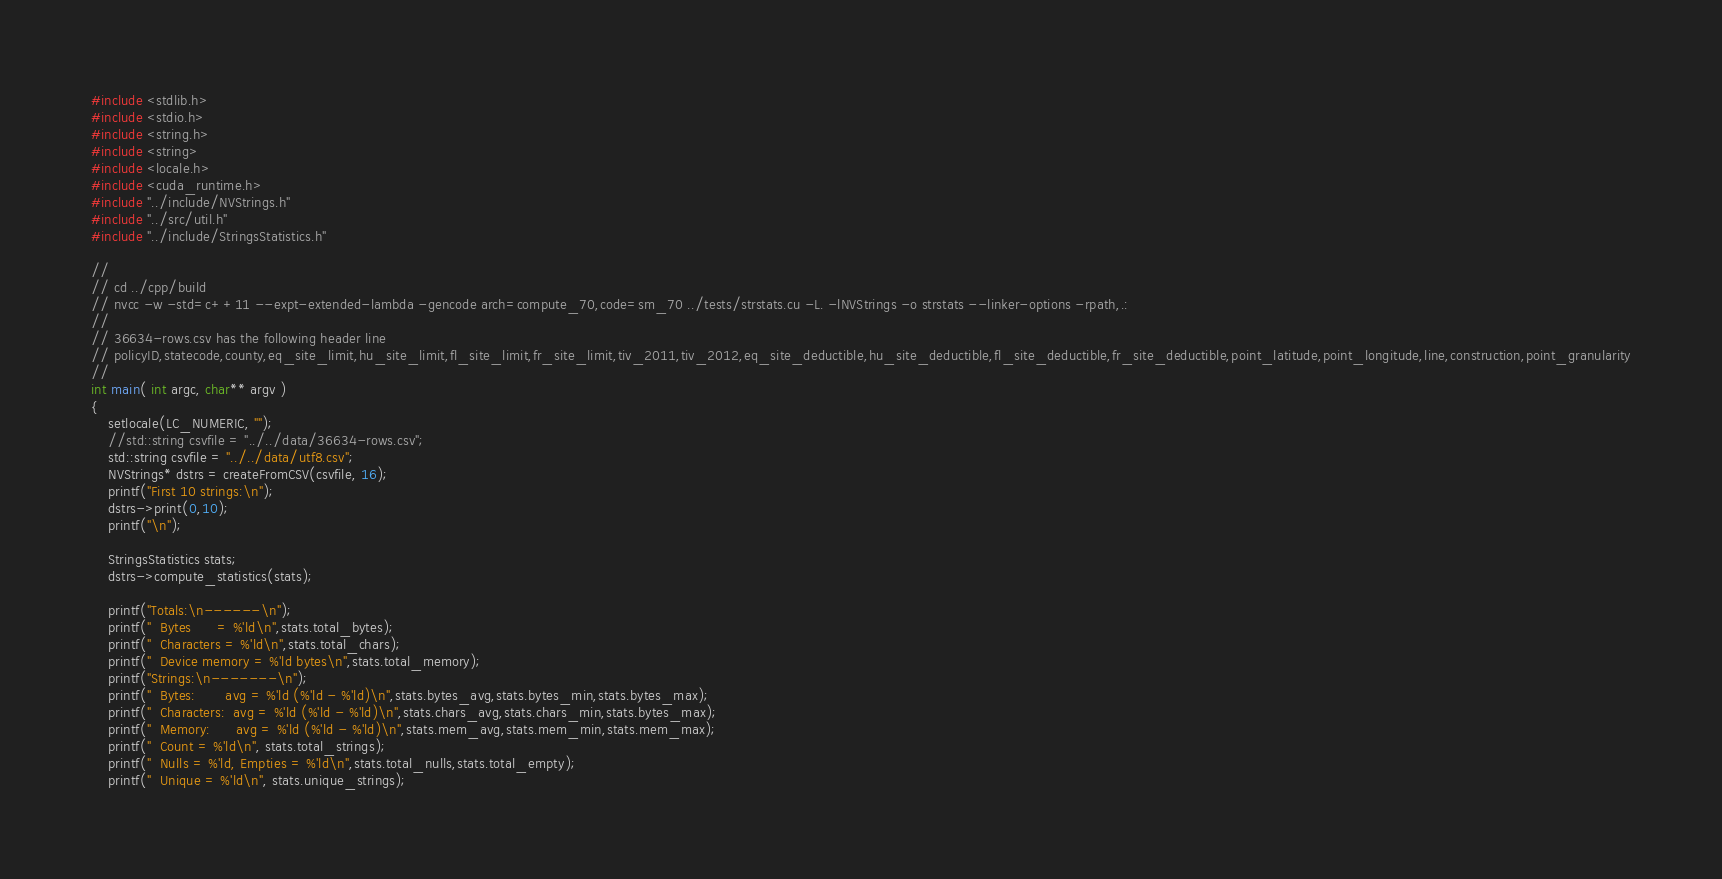<code> <loc_0><loc_0><loc_500><loc_500><_Cuda_>
#include <stdlib.h>
#include <stdio.h>
#include <string.h>
#include <string>
#include <locale.h>
#include <cuda_runtime.h>
#include "../include/NVStrings.h"
#include "../src/util.h"
#include "../include/StringsStatistics.h"

//
// cd ../cpp/build
// nvcc -w -std=c++11 --expt-extended-lambda -gencode arch=compute_70,code=sm_70 ../tests/strstats.cu -L. -lNVStrings -o strstats --linker-options -rpath,.:
//
// 36634-rows.csv has the following header line
// policyID,statecode,county,eq_site_limit,hu_site_limit,fl_site_limit,fr_site_limit,tiv_2011,tiv_2012,eq_site_deductible,hu_site_deductible,fl_site_deductible,fr_site_deductible,point_latitude,point_longitude,line,construction,point_granularity
//
int main( int argc, char** argv )
{
    setlocale(LC_NUMERIC, "");
    //std::string csvfile = "../../data/36634-rows.csv";
    std::string csvfile = "../../data/utf8.csv";
    NVStrings* dstrs = createFromCSV(csvfile, 16);
    printf("First 10 strings:\n");
    dstrs->print(0,10);
    printf("\n");

    StringsStatistics stats;
    dstrs->compute_statistics(stats);

    printf("Totals:\n------\n");
    printf("  Bytes      = %'ld\n",stats.total_bytes);
    printf("  Characters = %'ld\n",stats.total_chars);
    printf("  Device memory = %'ld bytes\n",stats.total_memory);
    printf("Strings:\n-------\n");
    printf("  Bytes:       avg = %'ld (%'ld - %'ld)\n",stats.bytes_avg,stats.bytes_min,stats.bytes_max);
    printf("  Characters:  avg = %'ld (%'ld - %'ld)\n",stats.chars_avg,stats.chars_min,stats.bytes_max);
    printf("  Memory:      avg = %'ld (%'ld - %'ld)\n",stats.mem_avg,stats.mem_min,stats.mem_max);
    printf("  Count = %'ld\n", stats.total_strings);
    printf("  Nulls = %'ld, Empties = %'ld\n",stats.total_nulls,stats.total_empty);    
    printf("  Unique = %'ld\n", stats.unique_strings);</code> 